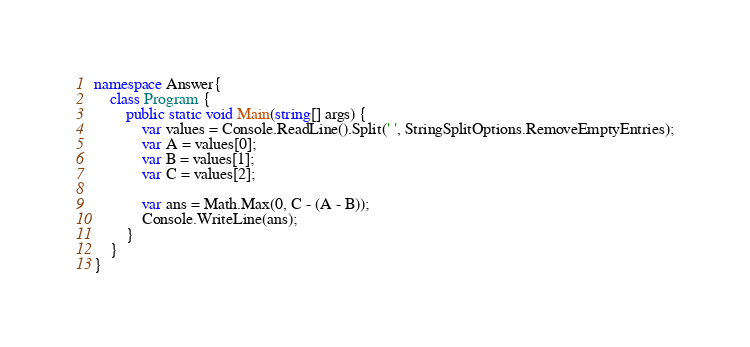Convert code to text. <code><loc_0><loc_0><loc_500><loc_500><_C#_>namespace Answer{
	class Program {
  		public static void Main(string[] args) {
    		var values = Console.ReadLine().Split(' ', StringSplitOptions.RemoveEmptyEntries);
    		var A = values[0];
    		var B = values[1];
    		var C = values[2];
    
    		var ans = Math.Max(0, C - (A - B));
    		Console.WriteLine(ans);
  		}
	}
}

</code> 